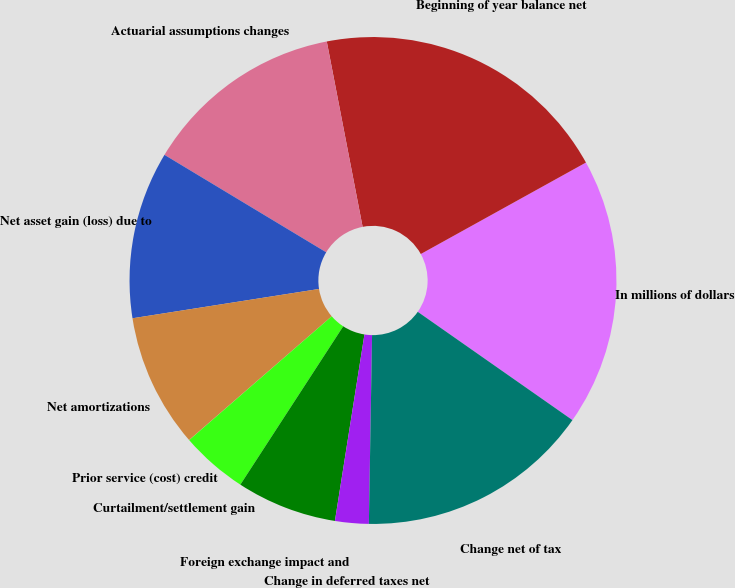Convert chart. <chart><loc_0><loc_0><loc_500><loc_500><pie_chart><fcel>In millions of dollars<fcel>Beginning of year balance net<fcel>Actuarial assumptions changes<fcel>Net asset gain (loss) due to<fcel>Net amortizations<fcel>Prior service (cost) credit<fcel>Curtailment/settlement gain<fcel>Foreign exchange impact and<fcel>Change in deferred taxes net<fcel>Change net of tax<nl><fcel>17.77%<fcel>19.99%<fcel>13.33%<fcel>11.11%<fcel>8.89%<fcel>0.01%<fcel>4.45%<fcel>6.67%<fcel>2.23%<fcel>15.55%<nl></chart> 